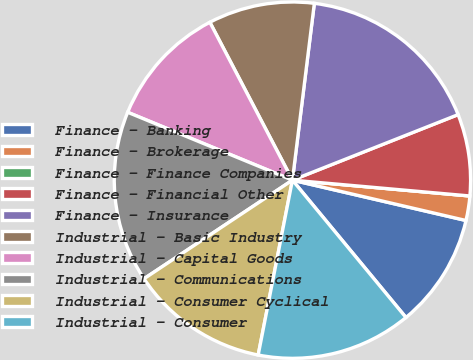<chart> <loc_0><loc_0><loc_500><loc_500><pie_chart><fcel>Finance - Banking<fcel>Finance - Brokerage<fcel>Finance - Finance Companies<fcel>Finance - Financial Other<fcel>Finance - Insurance<fcel>Industrial - Basic Industry<fcel>Industrial - Capital Goods<fcel>Industrial - Communications<fcel>Industrial - Consumer Cyclical<fcel>Industrial - Consumer<nl><fcel>10.37%<fcel>2.22%<fcel>0.0%<fcel>7.41%<fcel>17.04%<fcel>9.63%<fcel>11.11%<fcel>15.55%<fcel>12.59%<fcel>14.07%<nl></chart> 